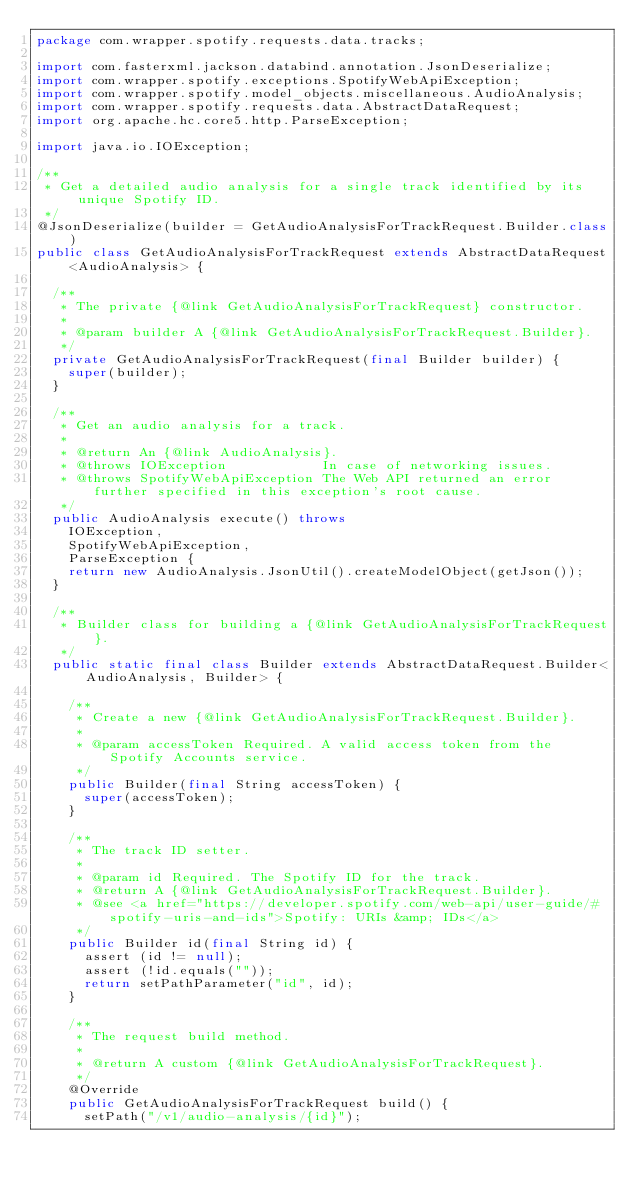<code> <loc_0><loc_0><loc_500><loc_500><_Java_>package com.wrapper.spotify.requests.data.tracks;

import com.fasterxml.jackson.databind.annotation.JsonDeserialize;
import com.wrapper.spotify.exceptions.SpotifyWebApiException;
import com.wrapper.spotify.model_objects.miscellaneous.AudioAnalysis;
import com.wrapper.spotify.requests.data.AbstractDataRequest;
import org.apache.hc.core5.http.ParseException;

import java.io.IOException;

/**
 * Get a detailed audio analysis for a single track identified by its unique Spotify ID.
 */
@JsonDeserialize(builder = GetAudioAnalysisForTrackRequest.Builder.class)
public class GetAudioAnalysisForTrackRequest extends AbstractDataRequest<AudioAnalysis> {

  /**
   * The private {@link GetAudioAnalysisForTrackRequest} constructor.
   *
   * @param builder A {@link GetAudioAnalysisForTrackRequest.Builder}.
   */
  private GetAudioAnalysisForTrackRequest(final Builder builder) {
    super(builder);
  }

  /**
   * Get an audio analysis for a track.
   *
   * @return An {@link AudioAnalysis}.
   * @throws IOException            In case of networking issues.
   * @throws SpotifyWebApiException The Web API returned an error further specified in this exception's root cause.
   */
  public AudioAnalysis execute() throws
    IOException,
    SpotifyWebApiException,
    ParseException {
    return new AudioAnalysis.JsonUtil().createModelObject(getJson());
  }

  /**
   * Builder class for building a {@link GetAudioAnalysisForTrackRequest}.
   */
  public static final class Builder extends AbstractDataRequest.Builder<AudioAnalysis, Builder> {

    /**
     * Create a new {@link GetAudioAnalysisForTrackRequest.Builder}.
     *
     * @param accessToken Required. A valid access token from the Spotify Accounts service.
     */
    public Builder(final String accessToken) {
      super(accessToken);
    }

    /**
     * The track ID setter.
     *
     * @param id Required. The Spotify ID for the track.
     * @return A {@link GetAudioAnalysisForTrackRequest.Builder}.
     * @see <a href="https://developer.spotify.com/web-api/user-guide/#spotify-uris-and-ids">Spotify: URIs &amp; IDs</a>
     */
    public Builder id(final String id) {
      assert (id != null);
      assert (!id.equals(""));
      return setPathParameter("id", id);
    }

    /**
     * The request build method.
     *
     * @return A custom {@link GetAudioAnalysisForTrackRequest}.
     */
    @Override
    public GetAudioAnalysisForTrackRequest build() {
      setPath("/v1/audio-analysis/{id}");</code> 